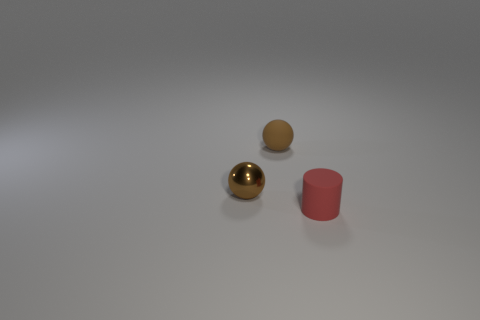Subtract 1 spheres. How many spheres are left? 1 Subtract all cylinders. How many objects are left? 2 Add 1 small things. How many objects exist? 4 Subtract all big blue shiny blocks. Subtract all rubber things. How many objects are left? 1 Add 2 brown balls. How many brown balls are left? 4 Add 3 rubber spheres. How many rubber spheres exist? 4 Subtract 0 cyan balls. How many objects are left? 3 Subtract all yellow cylinders. Subtract all red blocks. How many cylinders are left? 1 